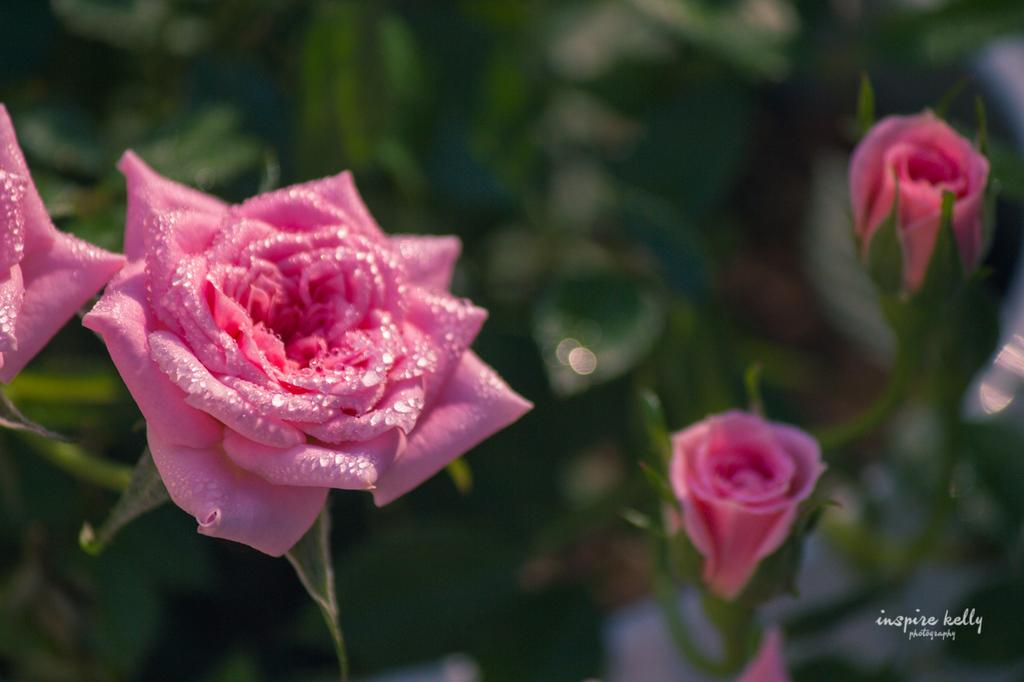What type of flowers are present in the image? There are pink color rose flowers in the image. What else can be seen in the image besides the flowers? There are leaves in the image. How would you describe the background of the image? The background of the image is blurry. Is there any text present in the image? Yes, there is some text at the right bottom of the image. Can you show me where the tent is located in the image? There is no tent present in the image. 